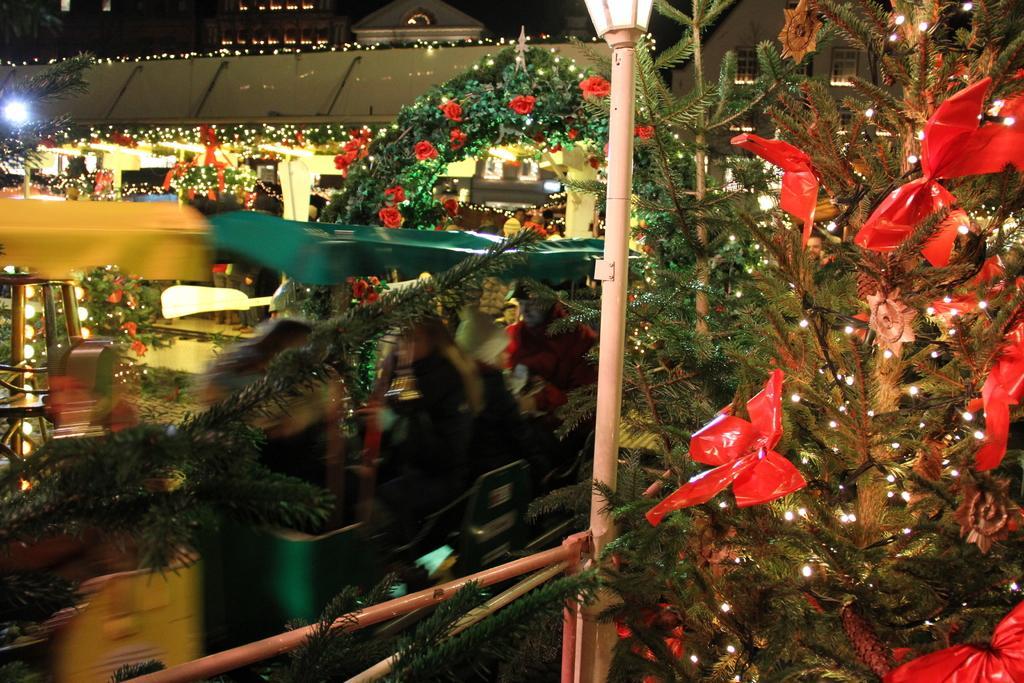Please provide a concise description of this image. In this image I can see few trees. There are lights on trees. At the top I can see two buildings. 